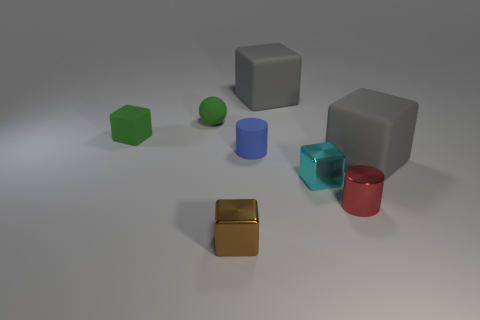Subtract all small rubber blocks. How many blocks are left? 4 Subtract all gray blocks. How many blocks are left? 3 Subtract 2 cubes. How many cubes are left? 3 Add 1 yellow shiny cylinders. How many objects exist? 9 Subtract all green blocks. Subtract all brown cylinders. How many blocks are left? 4 Subtract all spheres. How many objects are left? 7 Subtract 0 blue cubes. How many objects are left? 8 Subtract all tiny green matte blocks. Subtract all tiny purple shiny blocks. How many objects are left? 7 Add 1 tiny objects. How many tiny objects are left? 7 Add 6 balls. How many balls exist? 7 